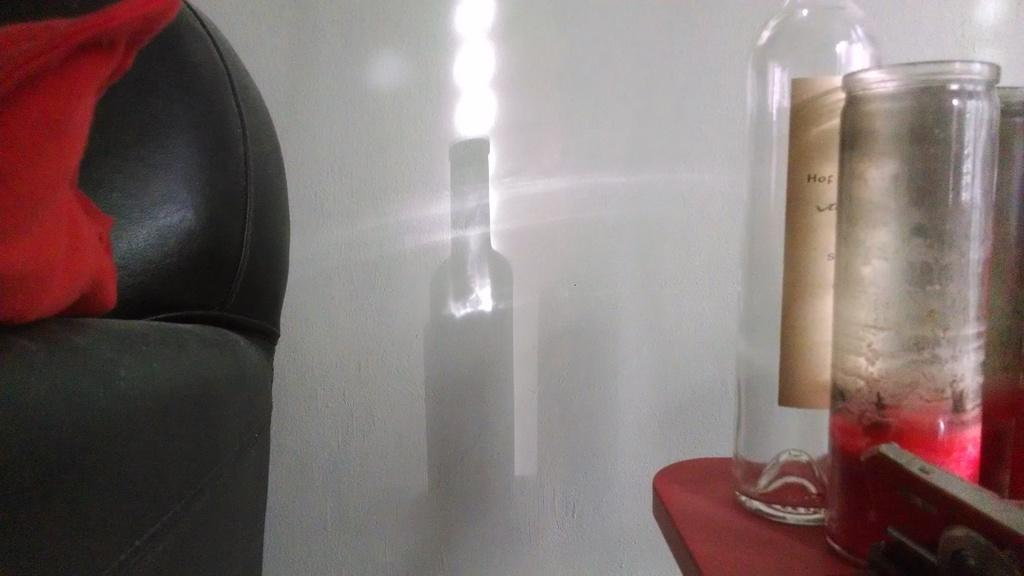What is the main object in the image? There is a table in the image. What items can be seen on the table? There are bottles on the table. Can you describe any visual effects in the image? Yes, there are reflections of a bottle and lights in the image. Is there a credit card visible on the table in the image? There is no mention of a credit card in the provided facts, so it cannot be determined if one is present in the image. 